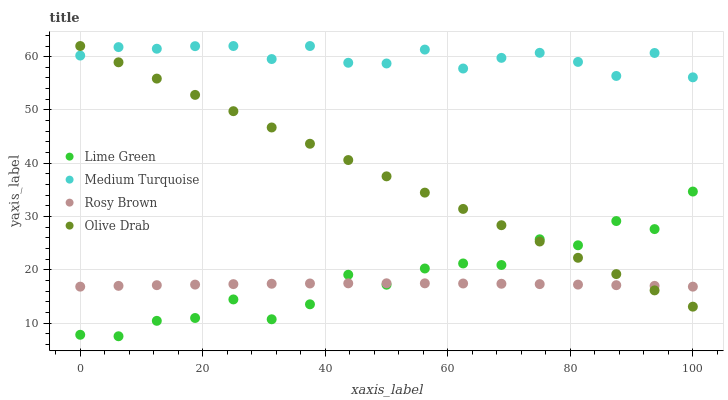Does Rosy Brown have the minimum area under the curve?
Answer yes or no. Yes. Does Medium Turquoise have the maximum area under the curve?
Answer yes or no. Yes. Does Lime Green have the minimum area under the curve?
Answer yes or no. No. Does Lime Green have the maximum area under the curve?
Answer yes or no. No. Is Olive Drab the smoothest?
Answer yes or no. Yes. Is Lime Green the roughest?
Answer yes or no. Yes. Is Lime Green the smoothest?
Answer yes or no. No. Is Olive Drab the roughest?
Answer yes or no. No. Does Lime Green have the lowest value?
Answer yes or no. Yes. Does Olive Drab have the lowest value?
Answer yes or no. No. Does Medium Turquoise have the highest value?
Answer yes or no. Yes. Does Lime Green have the highest value?
Answer yes or no. No. Is Rosy Brown less than Medium Turquoise?
Answer yes or no. Yes. Is Medium Turquoise greater than Rosy Brown?
Answer yes or no. Yes. Does Olive Drab intersect Medium Turquoise?
Answer yes or no. Yes. Is Olive Drab less than Medium Turquoise?
Answer yes or no. No. Is Olive Drab greater than Medium Turquoise?
Answer yes or no. No. Does Rosy Brown intersect Medium Turquoise?
Answer yes or no. No. 